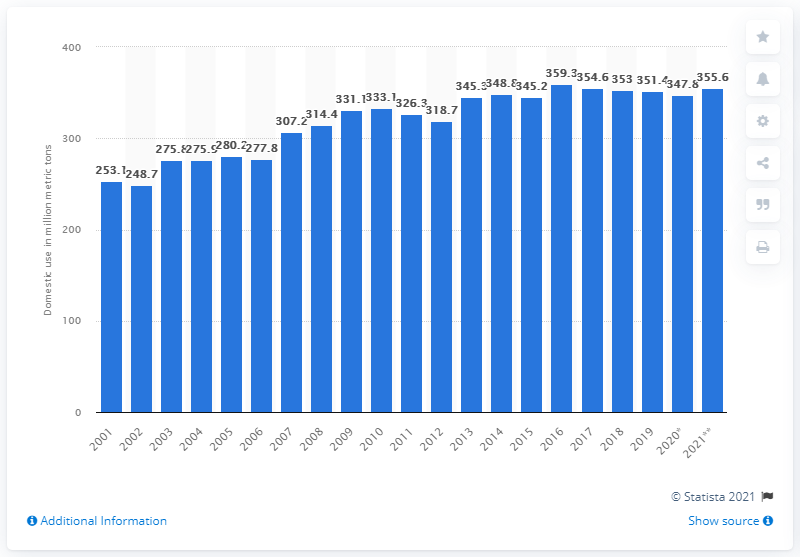Identify some key points in this picture. In 2020, the total domestic use of grain in the United States was 347.8 million bushels. 